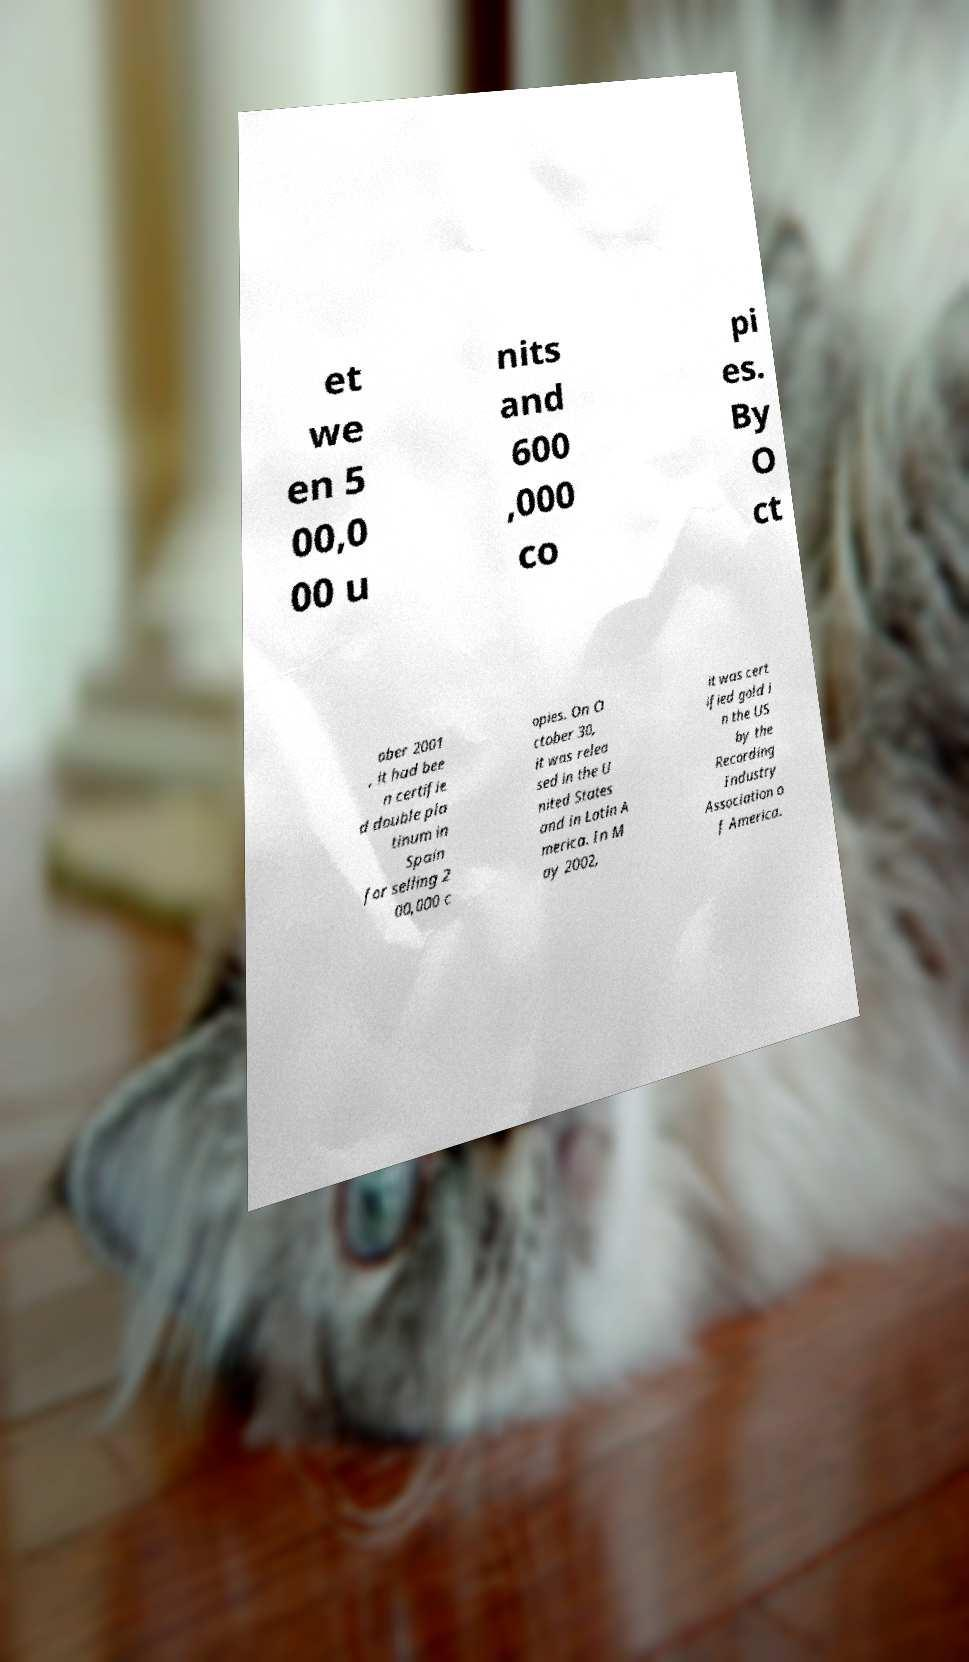I need the written content from this picture converted into text. Can you do that? et we en 5 00,0 00 u nits and 600 ,000 co pi es. By O ct ober 2001 , it had bee n certifie d double pla tinum in Spain for selling 2 00,000 c opies. On O ctober 30, it was relea sed in the U nited States and in Latin A merica. In M ay 2002, it was cert ified gold i n the US by the Recording Industry Association o f America. 